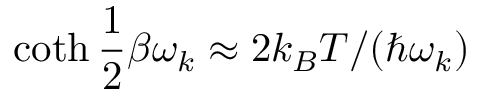Convert formula to latex. <formula><loc_0><loc_0><loc_500><loc_500>\coth \frac { 1 } { 2 } \beta \omega _ { k } \approx 2 k _ { B } T / ( \hbar { \omega } _ { k } )</formula> 